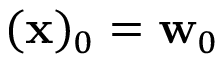Convert formula to latex. <formula><loc_0><loc_0><loc_500><loc_500>( x ) _ { 0 } = w _ { 0 }</formula> 